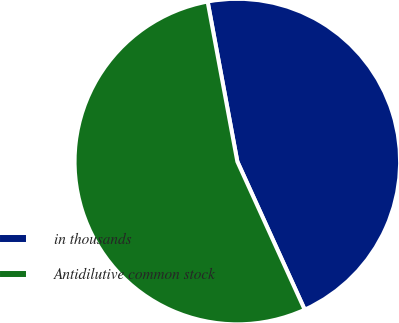<chart> <loc_0><loc_0><loc_500><loc_500><pie_chart><fcel>in thousands<fcel>Antidilutive common stock<nl><fcel>46.13%<fcel>53.87%<nl></chart> 